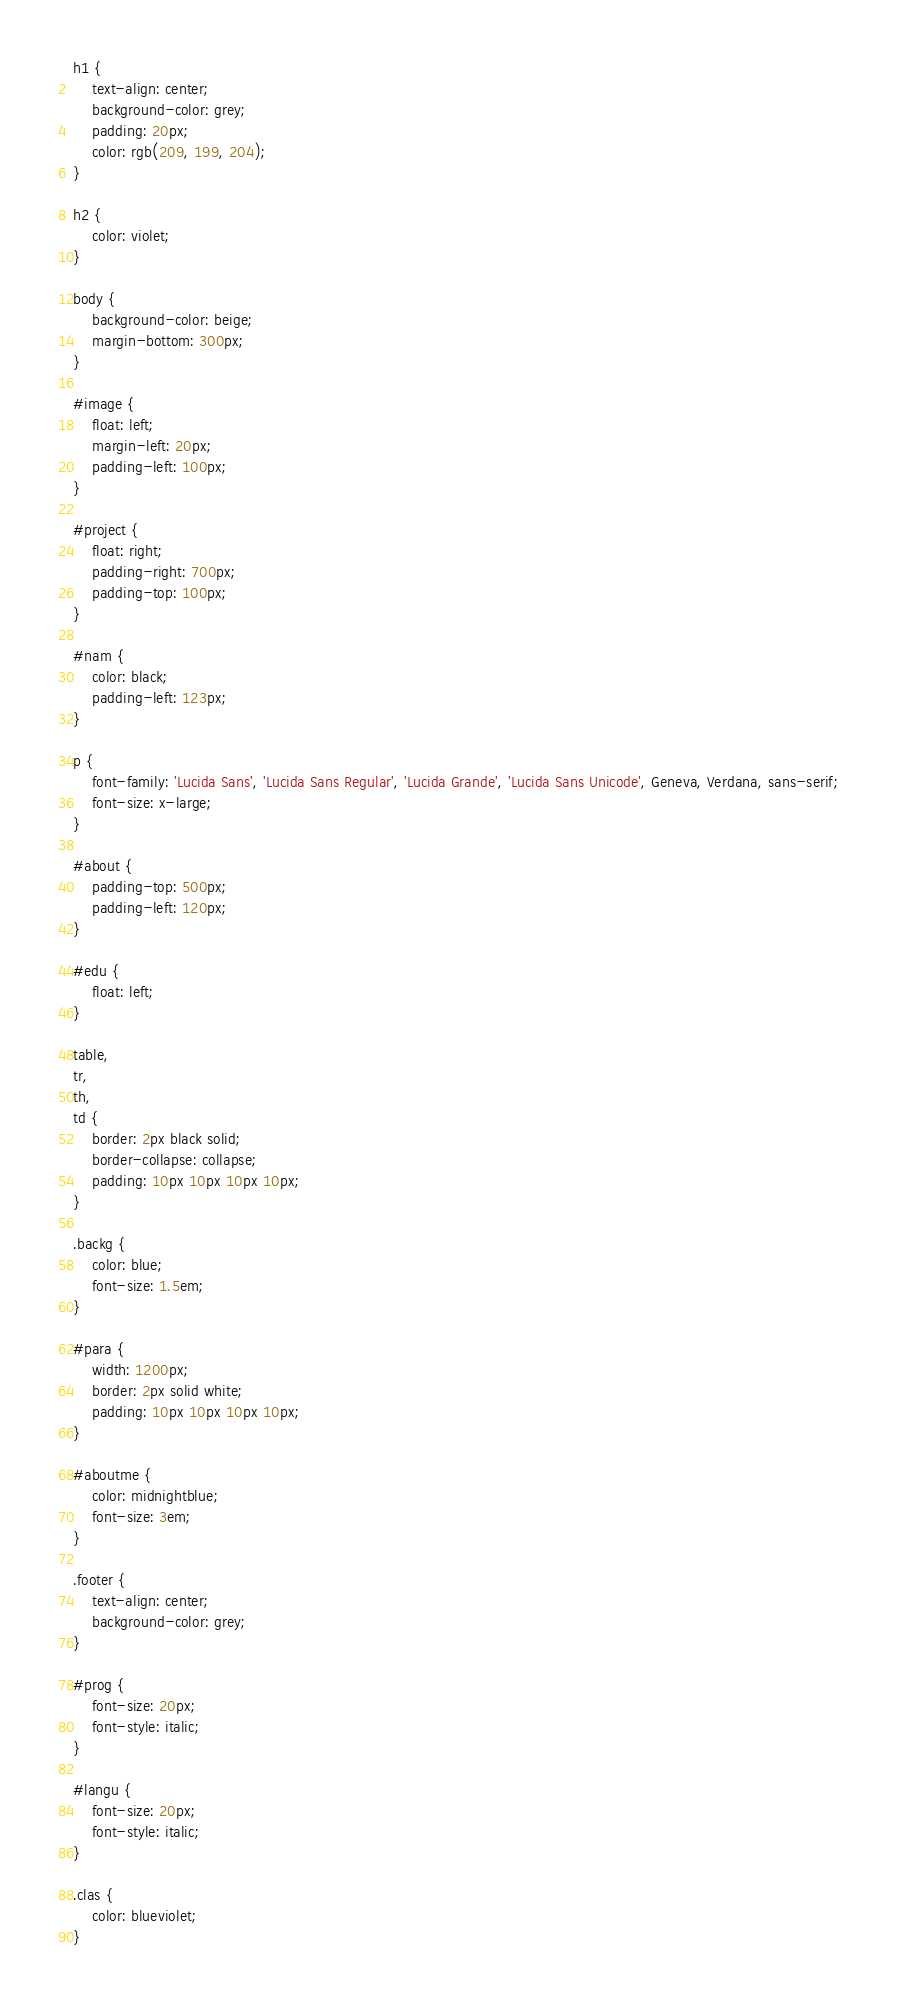Convert code to text. <code><loc_0><loc_0><loc_500><loc_500><_CSS_>h1 {
    text-align: center;
    background-color: grey;
    padding: 20px;
    color: rgb(209, 199, 204);
}

h2 {
    color: violet;
}

body {
    background-color: beige;
    margin-bottom: 300px;
}

#image {
    float: left;
    margin-left: 20px;
    padding-left: 100px;
}

#project {
    float: right;
    padding-right: 700px;
    padding-top: 100px;
}

#nam {
    color: black;
    padding-left: 123px;
}

p {
    font-family: 'Lucida Sans', 'Lucida Sans Regular', 'Lucida Grande', 'Lucida Sans Unicode', Geneva, Verdana, sans-serif;
    font-size: x-large;
}

#about {
    padding-top: 500px;
    padding-left: 120px;
}

#edu {
    float: left;
}

table,
tr,
th,
td {
    border: 2px black solid;
    border-collapse: collapse;
    padding: 10px 10px 10px 10px;
}

.backg {
    color: blue;
    font-size: 1.5em;
}

#para {
    width: 1200px;
    border: 2px solid white;
    padding: 10px 10px 10px 10px;
}

#aboutme {
    color: midnightblue;
    font-size: 3em;
}

.footer {
    text-align: center;
    background-color: grey;
}

#prog {
    font-size: 20px;
    font-style: italic;
}

#langu {
    font-size: 20px;
    font-style: italic;
}

.clas {
    color: blueviolet;
}</code> 